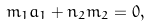Convert formula to latex. <formula><loc_0><loc_0><loc_500><loc_500>m _ { 1 } a _ { 1 } + n _ { 2 } m _ { 2 } = 0 ,</formula> 